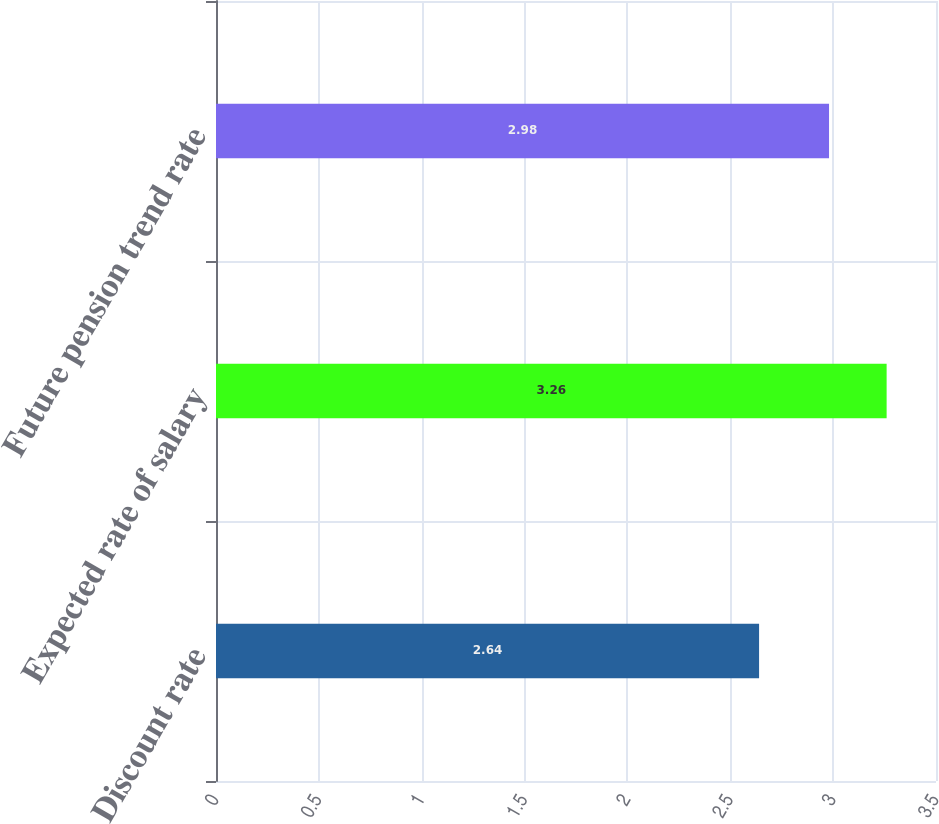Convert chart to OTSL. <chart><loc_0><loc_0><loc_500><loc_500><bar_chart><fcel>Discount rate<fcel>Expected rate of salary<fcel>Future pension trend rate<nl><fcel>2.64<fcel>3.26<fcel>2.98<nl></chart> 